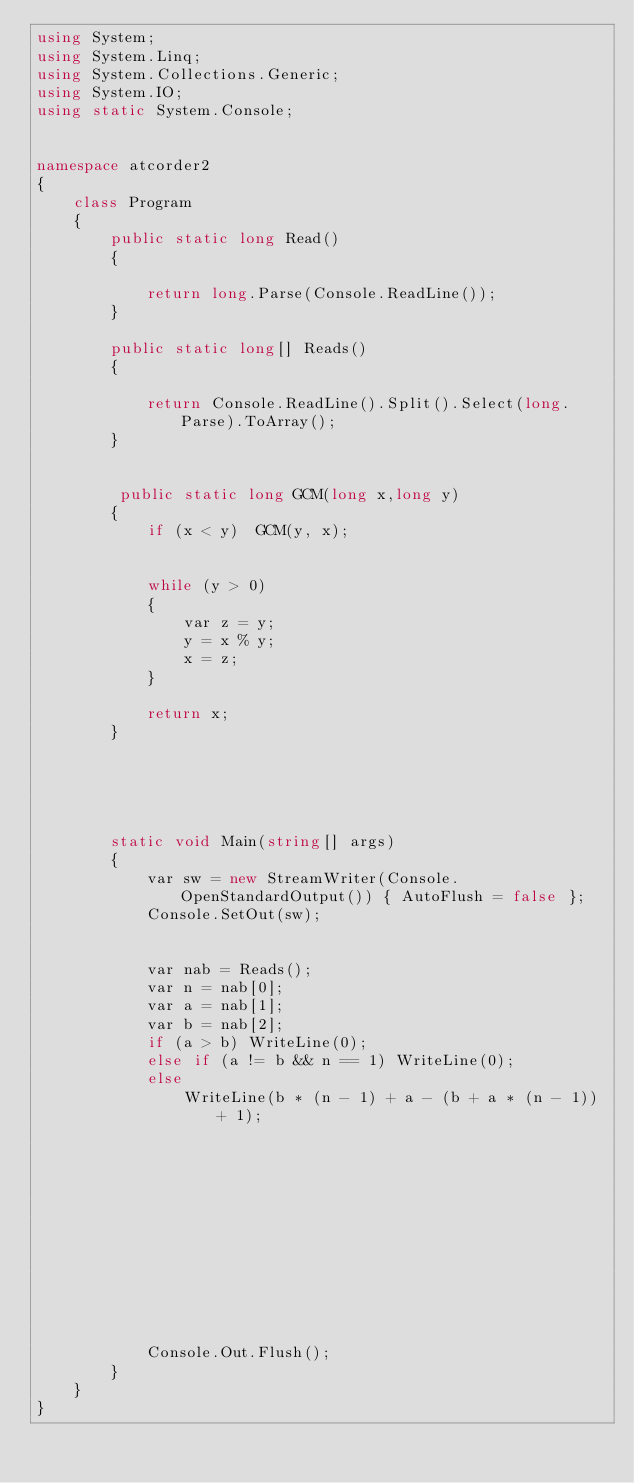<code> <loc_0><loc_0><loc_500><loc_500><_C#_>using System;
using System.Linq;
using System.Collections.Generic;
using System.IO;
using static System.Console;


namespace atcorder2
{
    class Program
    {
        public static long Read()
        {

            return long.Parse(Console.ReadLine());
        }

        public static long[] Reads()
        {

            return Console.ReadLine().Split().Select(long.Parse).ToArray();
        }

       
         public static long GCM(long x,long y)
        {
            if (x < y)  GCM(y, x);


            while (y > 0)
            {
                var z = y;
                y = x % y;
                x = z;
            }
            
            return x;
        }

        



        static void Main(string[] args)
        {
            var sw = new StreamWriter(Console.OpenStandardOutput()) { AutoFlush = false };
            Console.SetOut(sw);


            var nab = Reads();
            var n = nab[0];
            var a = nab[1];
            var b = nab[2];
            if (a > b) WriteLine(0);
            else if (a != b && n == 1) WriteLine(0);
            else
                WriteLine(b * (n - 1) + a - (b + a * (n - 1)) + 1);












            Console.Out.Flush();
        }
    }
}


</code> 